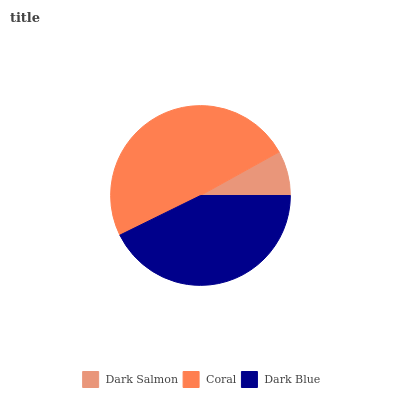Is Dark Salmon the minimum?
Answer yes or no. Yes. Is Coral the maximum?
Answer yes or no. Yes. Is Dark Blue the minimum?
Answer yes or no. No. Is Dark Blue the maximum?
Answer yes or no. No. Is Coral greater than Dark Blue?
Answer yes or no. Yes. Is Dark Blue less than Coral?
Answer yes or no. Yes. Is Dark Blue greater than Coral?
Answer yes or no. No. Is Coral less than Dark Blue?
Answer yes or no. No. Is Dark Blue the high median?
Answer yes or no. Yes. Is Dark Blue the low median?
Answer yes or no. Yes. Is Coral the high median?
Answer yes or no. No. Is Coral the low median?
Answer yes or no. No. 